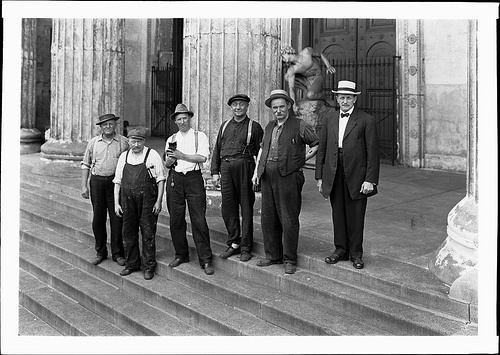Describe the objects in this image and their specific colors. I can see people in black, gray, lightgray, and darkgray tones, people in black, gray, darkgray, and lightgray tones, people in black, gray, darkgray, and lightgray tones, people in black, gray, lightgray, and darkgray tones, and people in black, lightgray, gray, and darkgray tones in this image. 